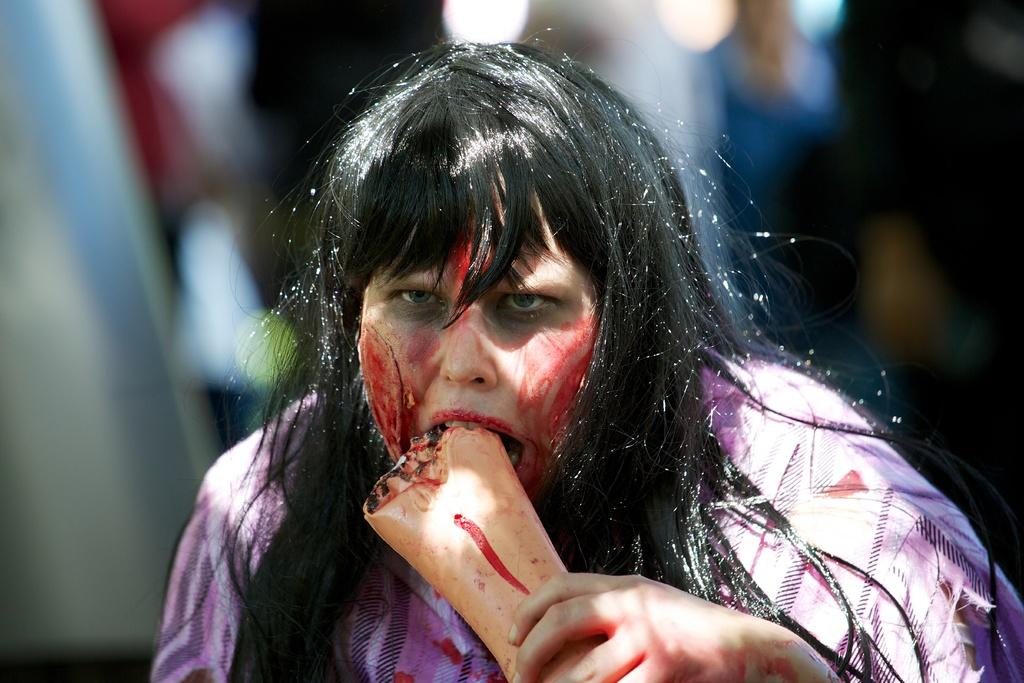Who is the main subject in the image? There is a woman in the image. What is the woman doing with her hand? The woman is holding a hand in her mouth. Can you describe the background of the image? The background of the image is blurred. What can be observed on the woman's face? There is red color on the woman's face. What type of canvas is the woman painting in the image? There is no canvas present in the image, and the woman is not painting. 